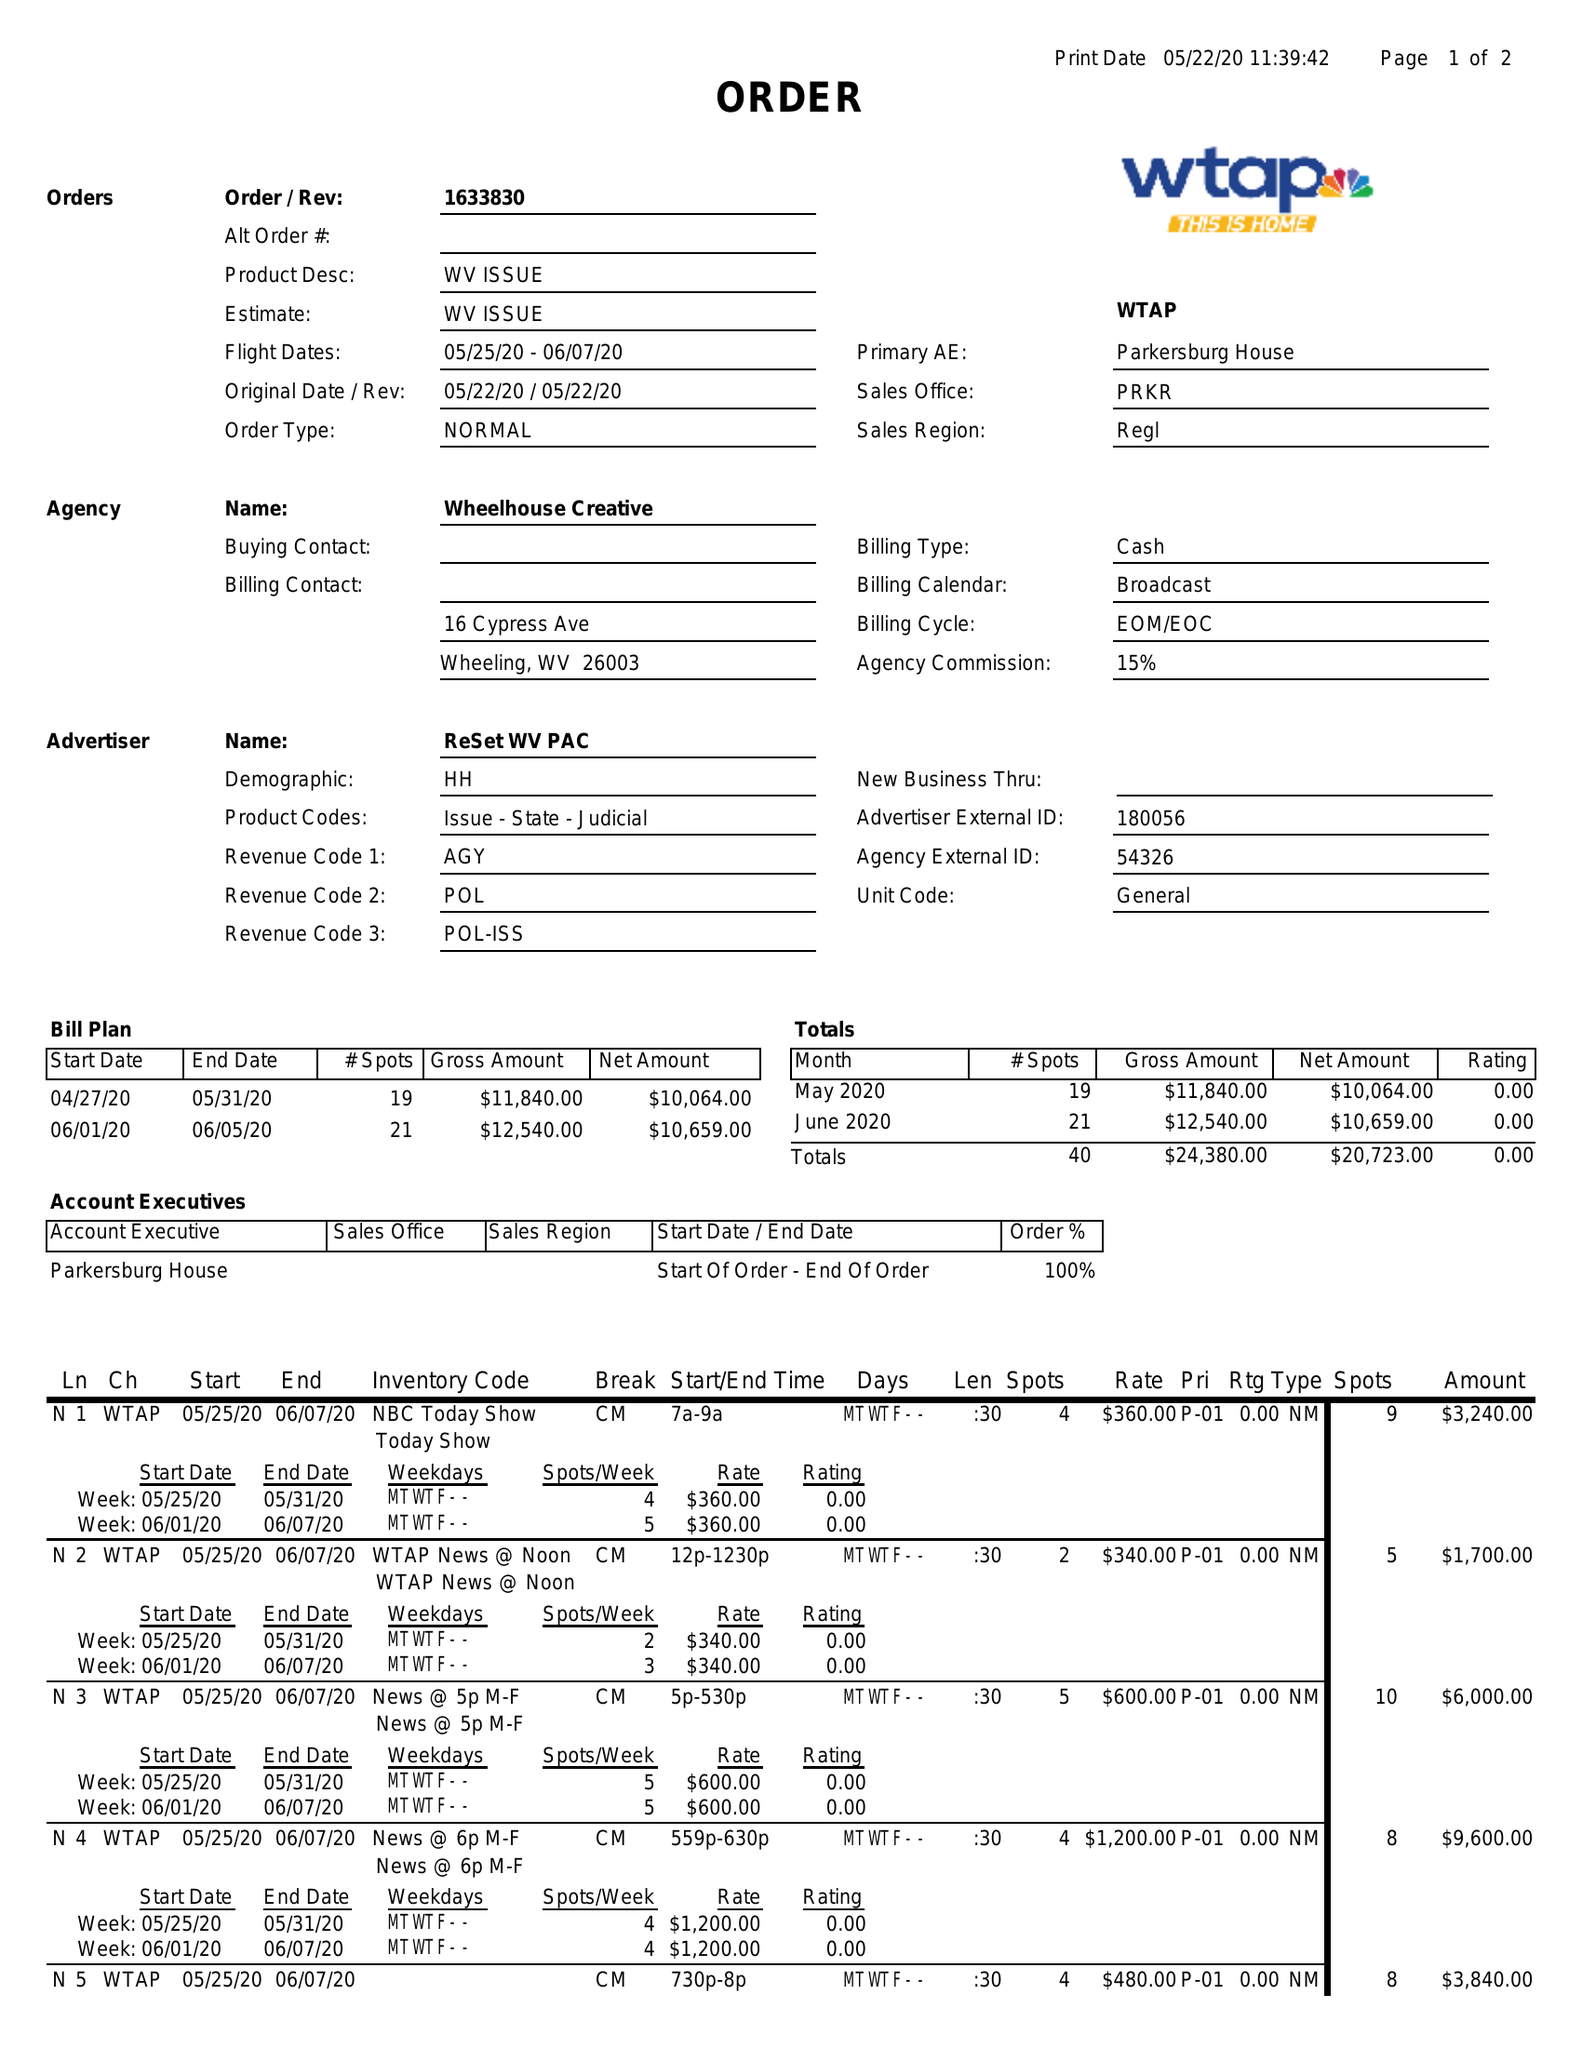What is the value for the gross_amount?
Answer the question using a single word or phrase. 24380.00 